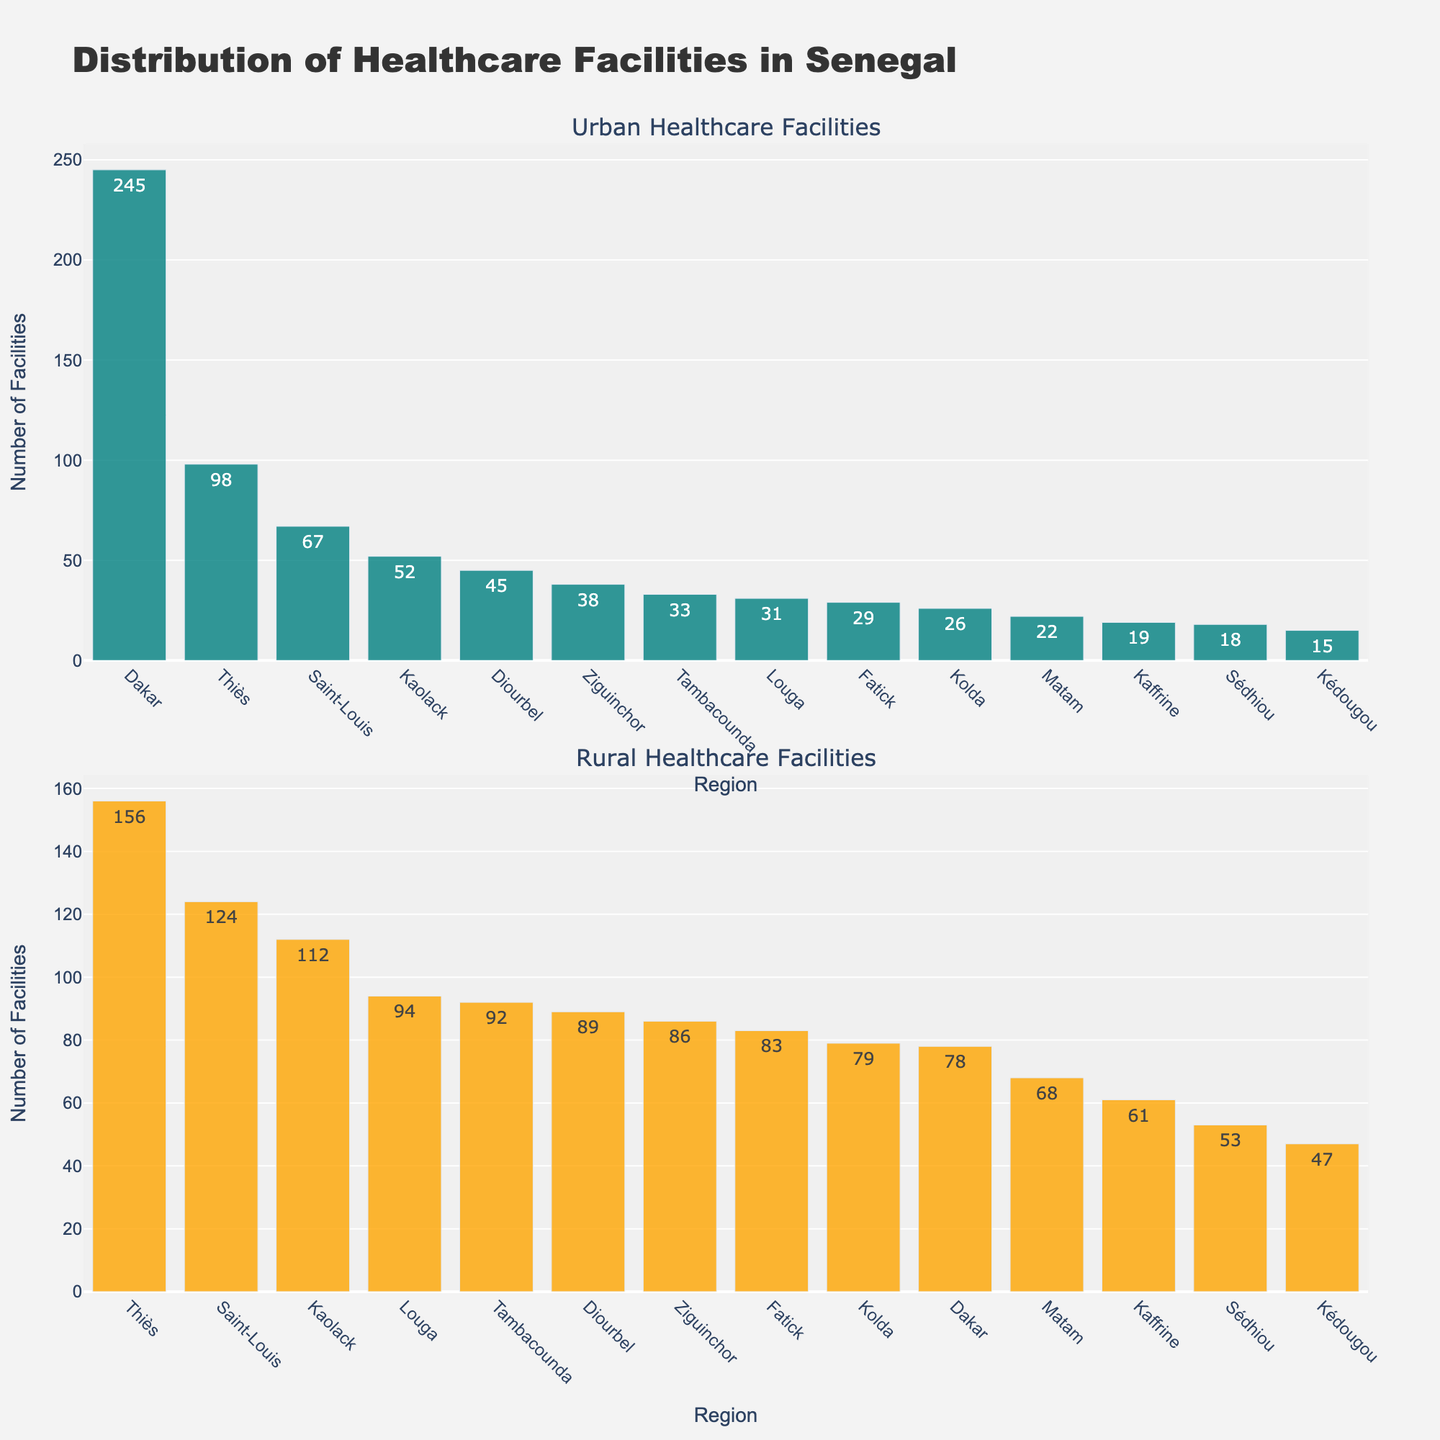Which area has the highest number of urban healthcare facilities? Look at the "Urban Healthcare Facilities" subplot and identify the tallest bar, which represents the highest number. Dakar Urban has the tallest bar.
Answer: Dakar Urban How many more healthcare facilities are there in rural Thiès compared to rural Kolda? In the "Rural Healthcare Facilities" subplot, find the bars for Thiès Rural and Kolda Rural. Thiès Rural has 156 facilities, and Kolda Rural has 79 facilities. The difference is 156 - 79 = 77.
Answer: 77 What is the total number of healthcare facilities in urban areas across all regions? Add the numbers for all urban areas: 245 (Dakar) + 98 (Thiès) + 67 (Saint-Louis) + 45 (Diourbel) + 52 (Kaolack) + 38 (Ziguinchor) + 31 (Louga) + 29 (Fatick) + 26 (Kolda) + 22 (Matam) + 19 (Kaffrine) + 33 (Tambacounda) + 15 (Kédougou) + 18 (Sédhiou) = 738.
Answer: 738 Which region has a more balanced distribution of healthcare facilities between urban and rural areas? Compare the differences between urban and rural facilities for each region. Thiès has 98 urban and 156 rural, a difference of 58. This gender balance seems more balanced when compared to regions like Dakar (difference 167) or Kolda (difference 53).
Answer: Thiès What is the median number of healthcare facilities in rural areas? Rank the rural numbers: 78, 83, 86, 89, 92, 94, 112, 124, 156. The middle value in this sorted list (9 values) is the 5th value (Matam rural, which is 79 facilities).
Answer: 89 By how much does Dakar Rural exceed Saint-Louis Rural in healthcare facilities? Dakar Rural has 78 facilities, and Saint-Louis Rural has 124 facilities. The difference is 124 - 78 = 46.
Answer: 46 Is there a region where the number of urban healthcare facilities is less than half of its rural counterpart? Check each region to see if the number listed for urban is less than half of the number listed for rural:
- Dakar: 245 is not less than half of 78
- Thiès: 98 is not less than half of 156
- Saint-Louis: 67 is slightly more than half of 124
- Diourbel: 45 is roughly half of 89
- Kaolack: 52 is roughly less than half of 112
- Ziguinchor: 38 is less than half of 86
- Louga: 31 is roughly half of 94
- Fatick: 29 is roughly half of 83
- Kolda: 26 is roughly half of 79
- Matam: 22 is less than half of 68
- Kaffrine: 19 is less than half of 61
- Tambacounda: 33 is slightly less than half of 92
- Kédougou: 15 is less than half of 47
- Sédhiou: 18 is slightly less than half of 53.
Answer: Yes Which urban area has the fewest healthcare facilities, and how many does it have? Look at the shortest bar in the "Urban Healthcare Facilities" subplot. Kédougou Urban has the fewest with 15 facilities.
Answer: Kédougou Urban, 15 What is the combined number of healthcare facilities in urban and rural areas of Louga? Add up the urban and rural numbers for Louga: 31 (urban) + 94 (rural) = 125.
Answer: 125 What is the difference in healthcare facilities between the urban areas of Kédougou and the rural areas of Kaffrine? Compare Kédougou Urban (15 facilities) with Kaffrine Rural (61 facilities). The difference is 61 - 15 = 46.
Answer: 46 